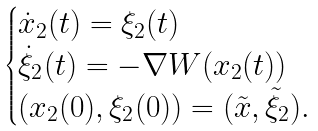<formula> <loc_0><loc_0><loc_500><loc_500>\begin{cases} \dot { x } _ { 2 } ( t ) = \xi _ { 2 } ( t ) \\ \dot { \xi } _ { 2 } ( t ) = - \nabla W ( x _ { 2 } ( t ) ) \\ ( x _ { 2 } ( 0 ) , \xi _ { 2 } ( 0 ) ) = ( \tilde { x } , \tilde { \xi } _ { 2 } ) . \end{cases}</formula> 